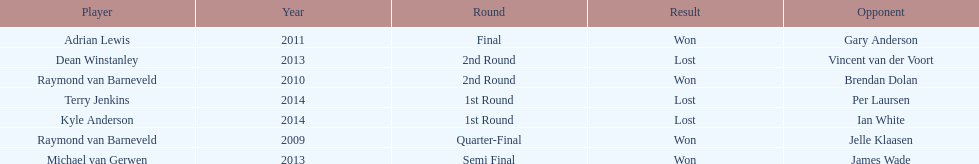Other than kyle anderson, who else lost in 2014? Terry Jenkins. 